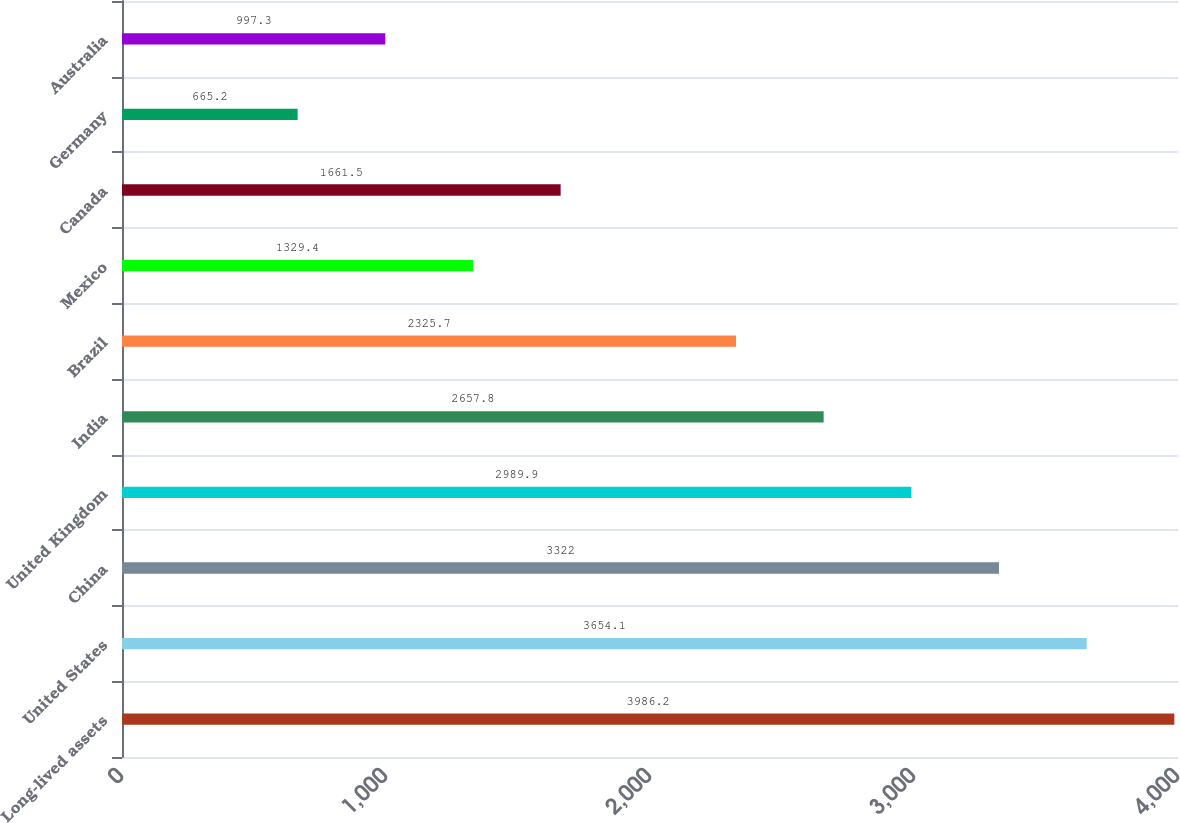Convert chart to OTSL. <chart><loc_0><loc_0><loc_500><loc_500><bar_chart><fcel>Long-lived assets<fcel>United States<fcel>China<fcel>United Kingdom<fcel>India<fcel>Brazil<fcel>Mexico<fcel>Canada<fcel>Germany<fcel>Australia<nl><fcel>3986.2<fcel>3654.1<fcel>3322<fcel>2989.9<fcel>2657.8<fcel>2325.7<fcel>1329.4<fcel>1661.5<fcel>665.2<fcel>997.3<nl></chart> 